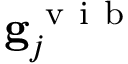Convert formula to latex. <formula><loc_0><loc_0><loc_500><loc_500>g _ { j } ^ { v i b }</formula> 